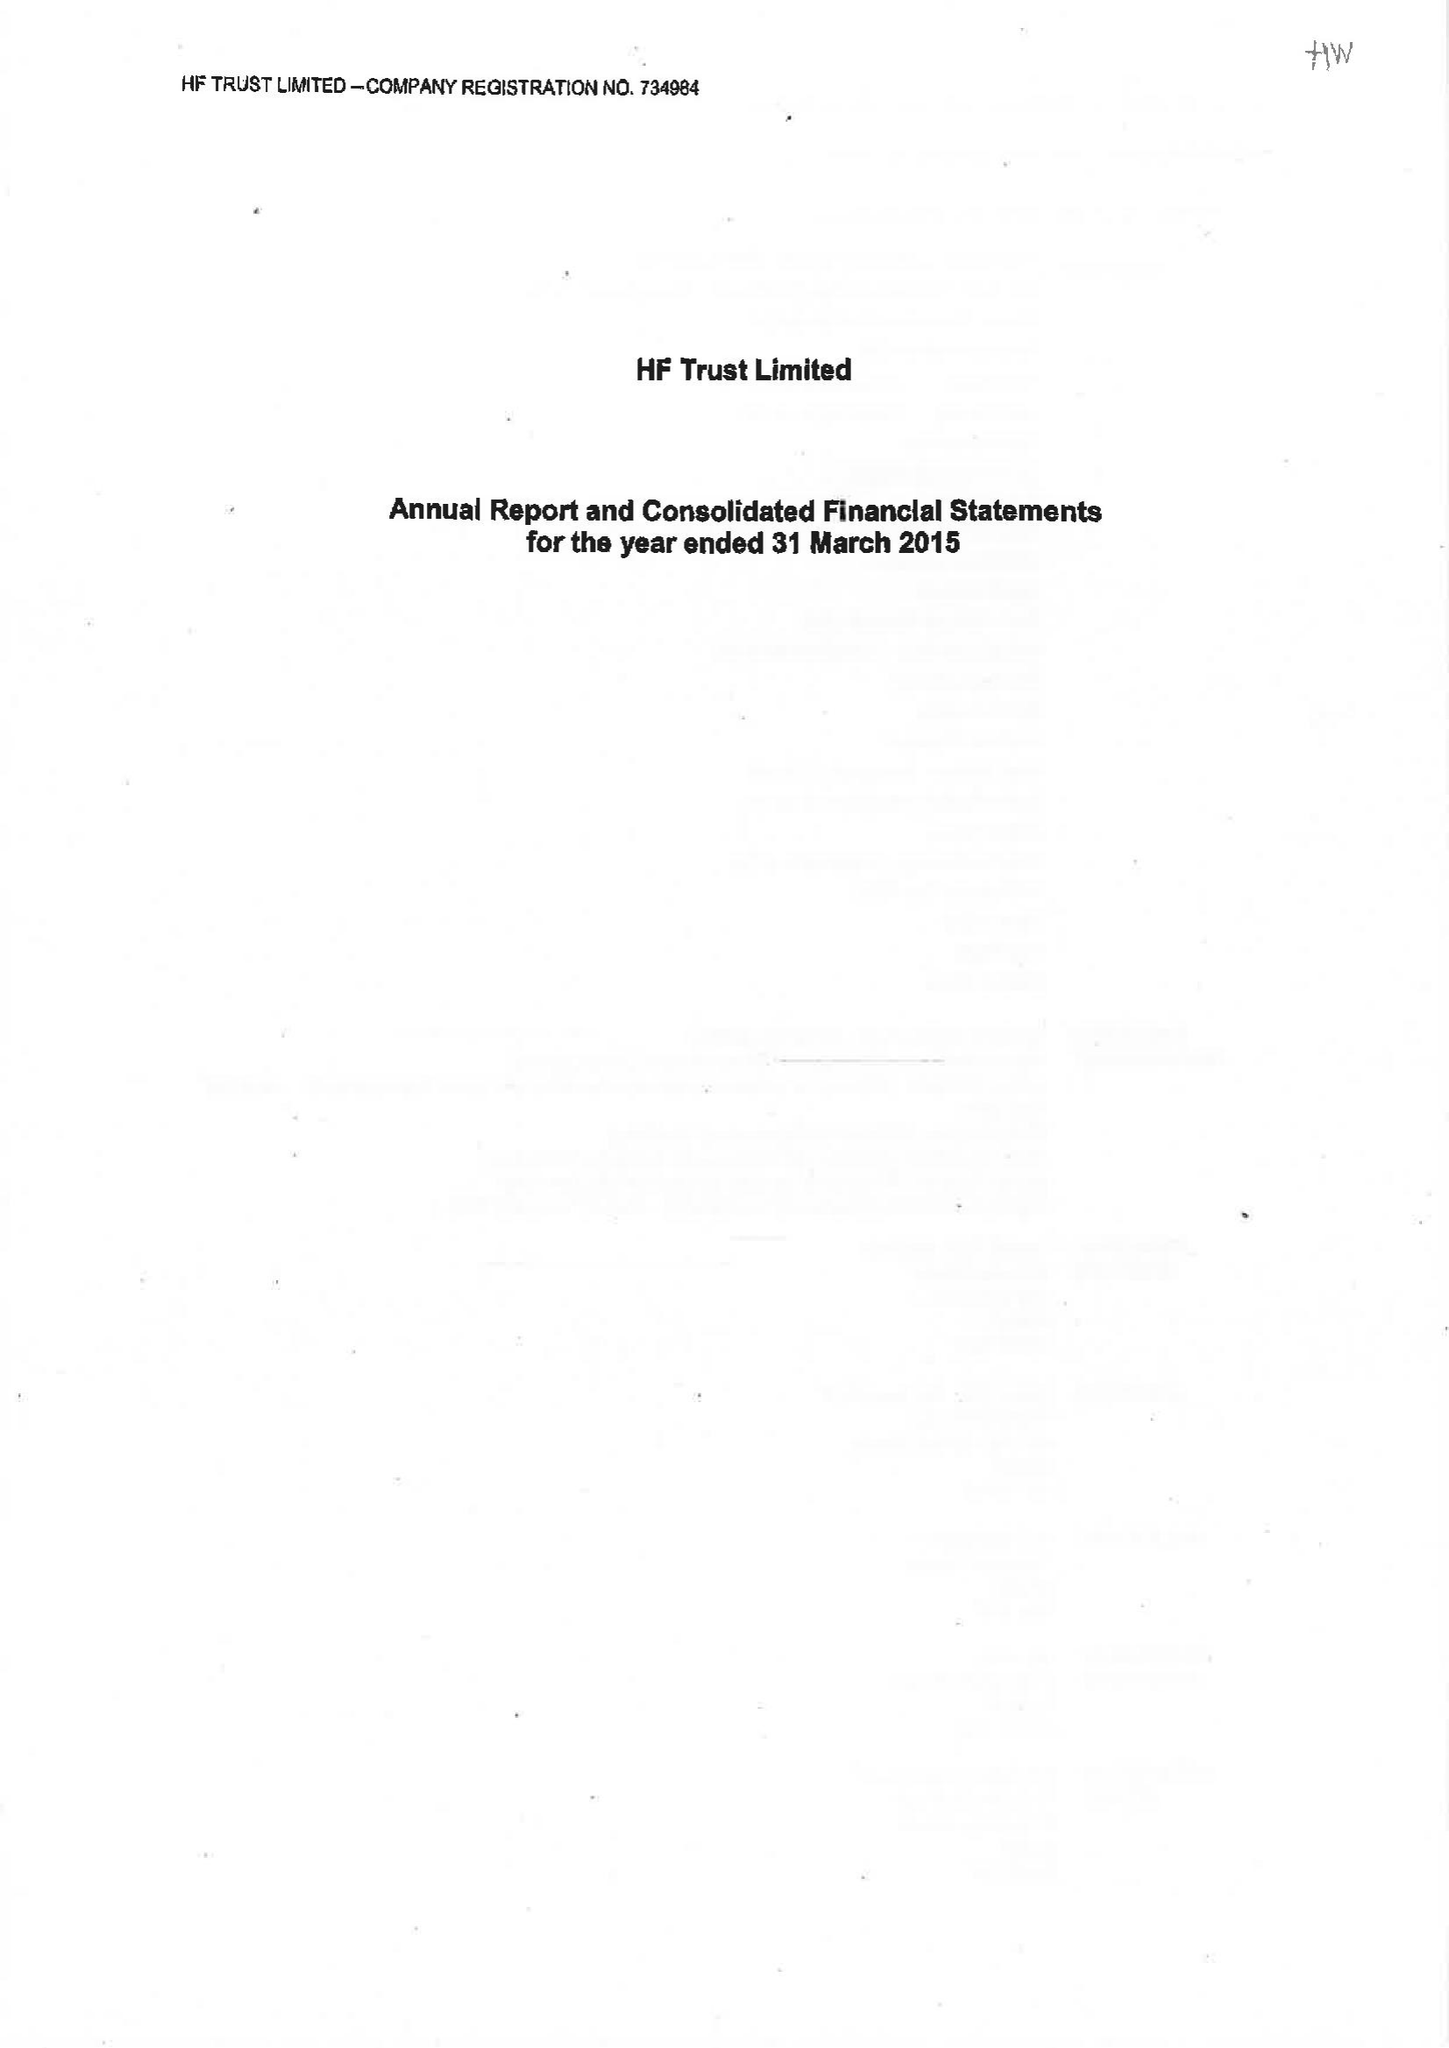What is the value for the charity_name?
Answer the question using a single word or phrase. Hf Trust Ltd. 